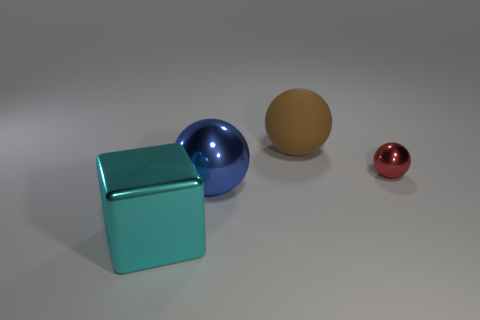Add 3 big cyan shiny objects. How many objects exist? 7 Subtract all blocks. How many objects are left? 3 Subtract 0 blue cubes. How many objects are left? 4 Subtract all brown shiny objects. Subtract all rubber balls. How many objects are left? 3 Add 3 brown matte spheres. How many brown matte spheres are left? 4 Add 1 cyan rubber blocks. How many cyan rubber blocks exist? 1 